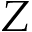<formula> <loc_0><loc_0><loc_500><loc_500>Z</formula> 